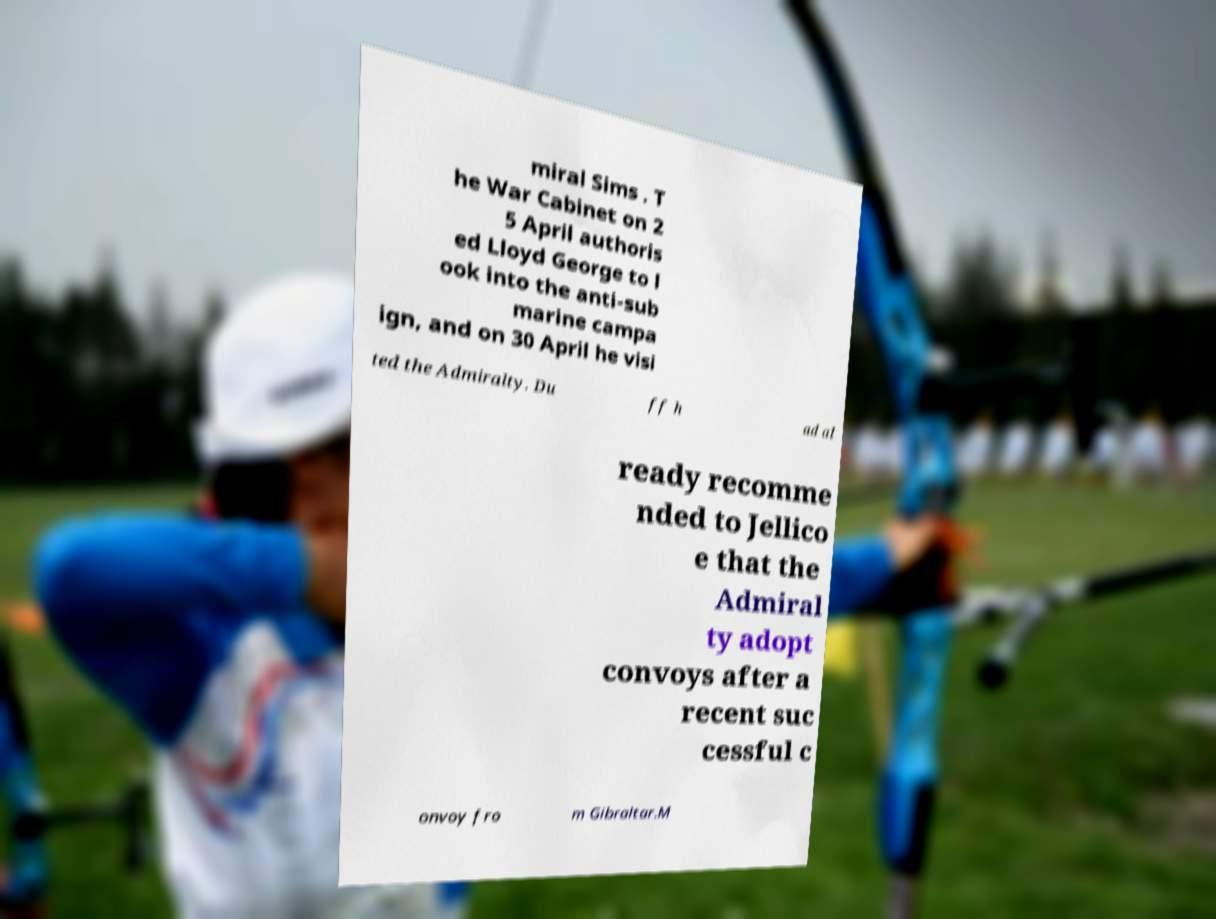Could you extract and type out the text from this image? miral Sims . T he War Cabinet on 2 5 April authoris ed Lloyd George to l ook into the anti-sub marine campa ign, and on 30 April he visi ted the Admiralty. Du ff h ad al ready recomme nded to Jellico e that the Admiral ty adopt convoys after a recent suc cessful c onvoy fro m Gibraltar.M 